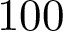Convert formula to latex. <formula><loc_0><loc_0><loc_500><loc_500>1 0 0</formula> 